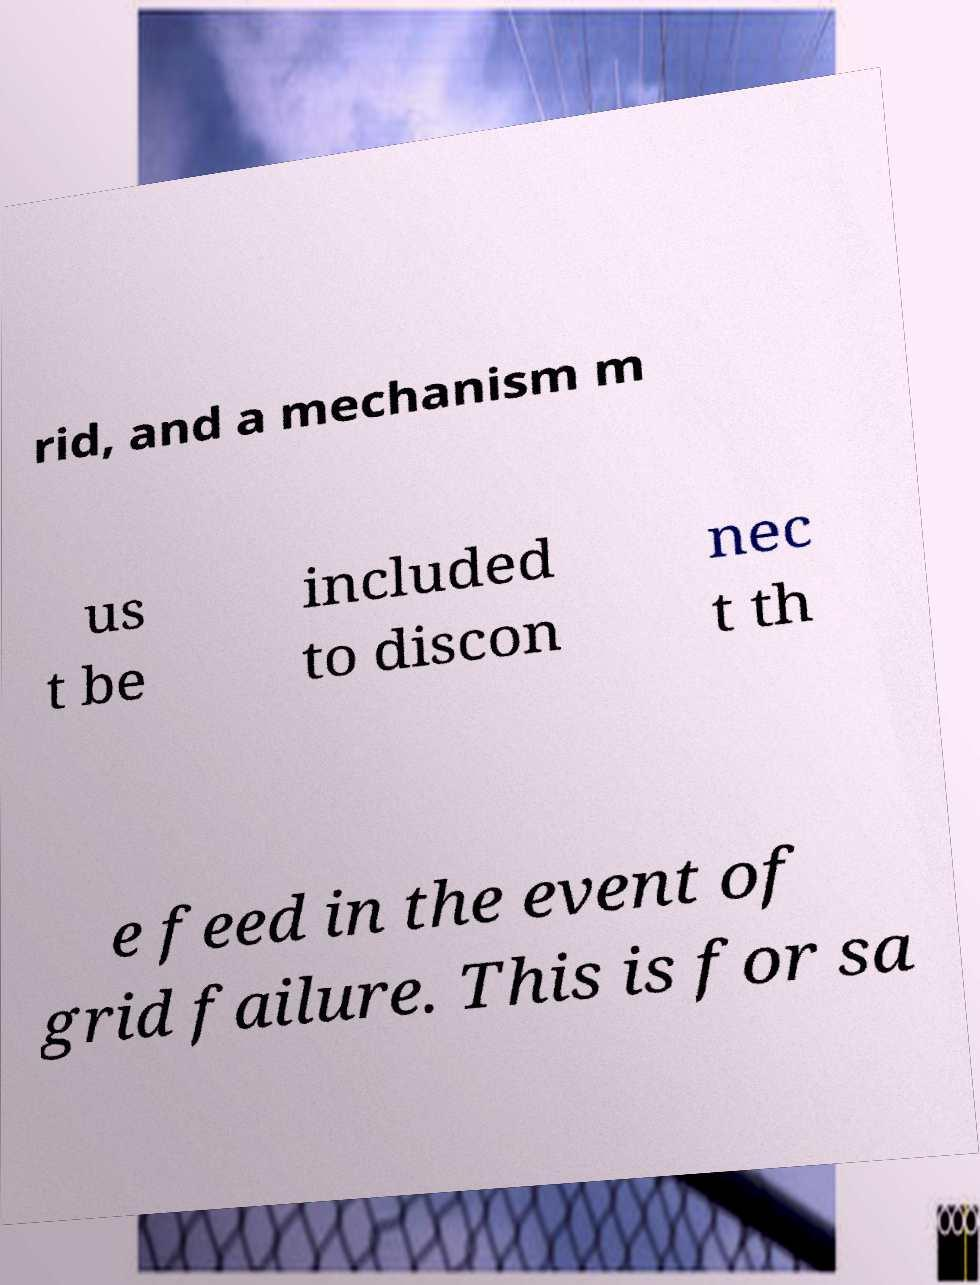Please identify and transcribe the text found in this image. rid, and a mechanism m us t be included to discon nec t th e feed in the event of grid failure. This is for sa 